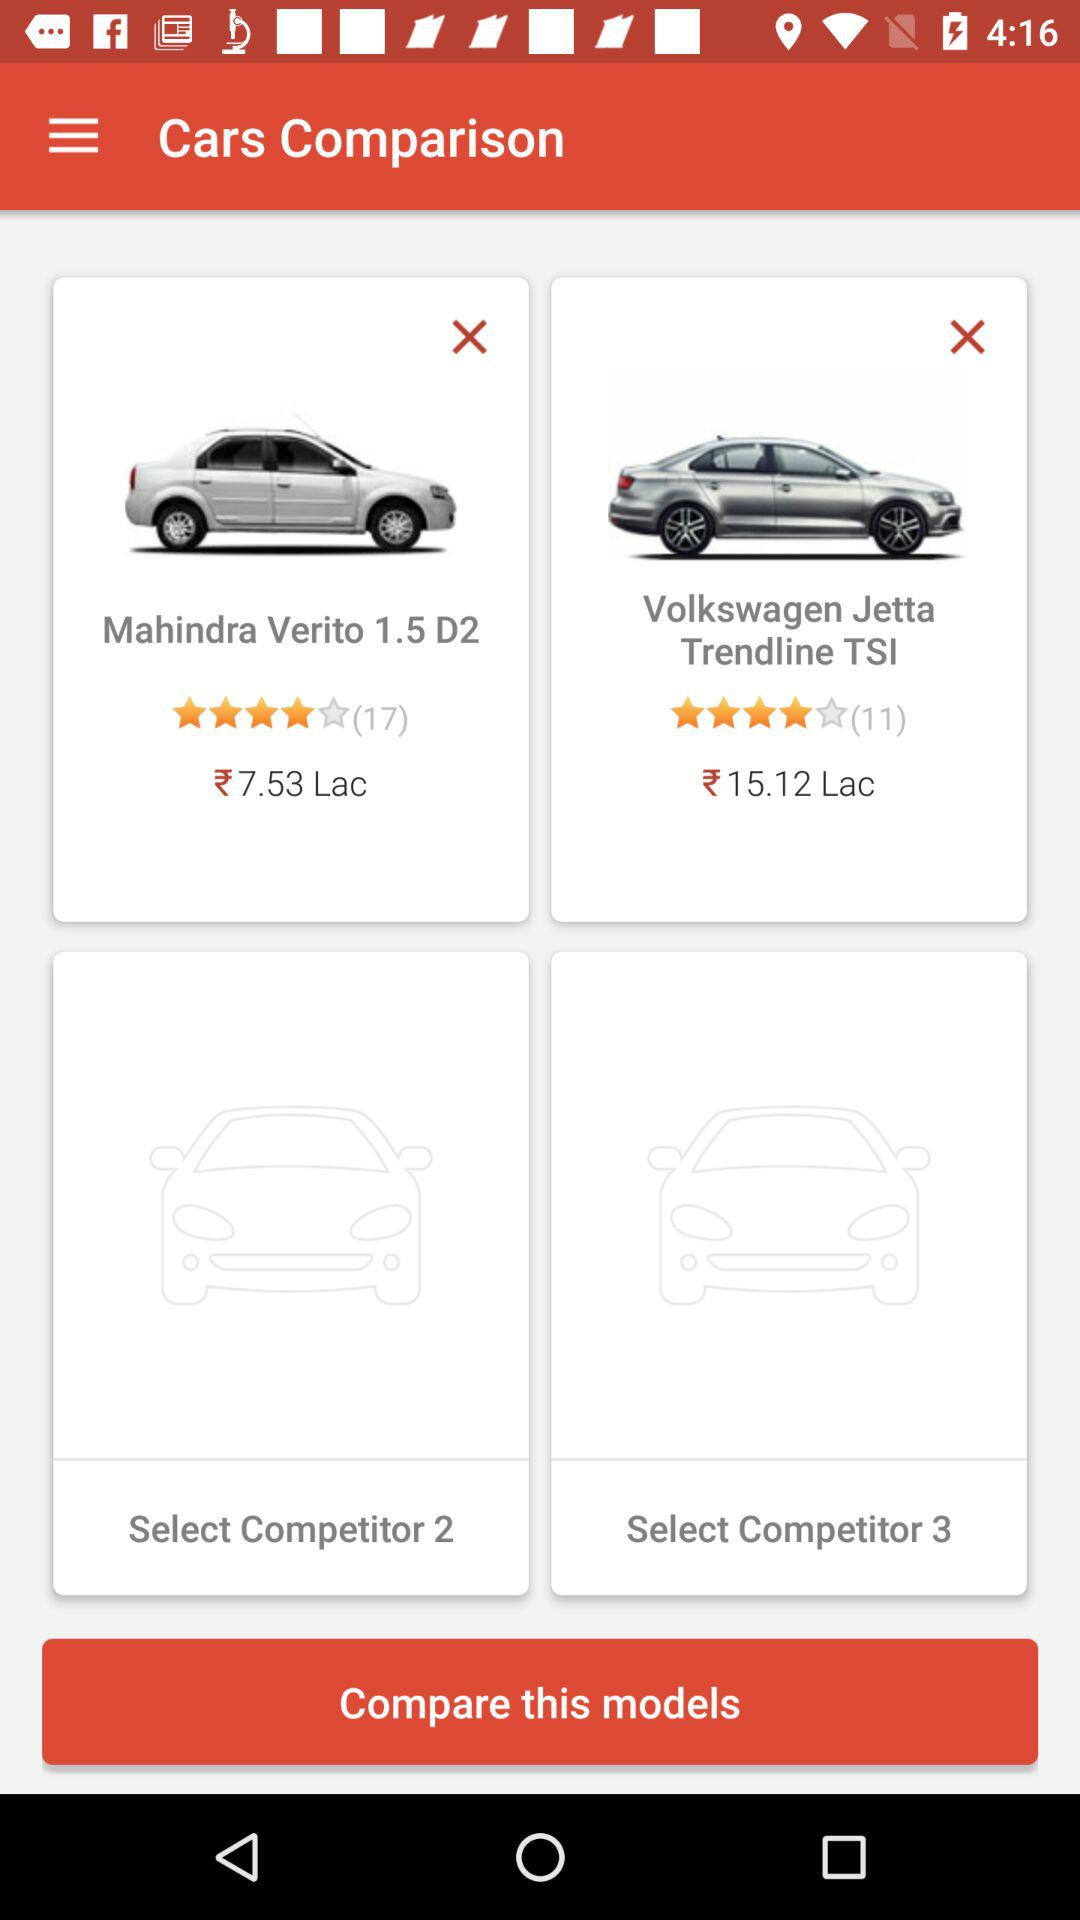What is the price of "Mahindra Verito 1.5 D2"? The price of "Mahindra Verito 1.5 D2" is ₹7.53 lac. 